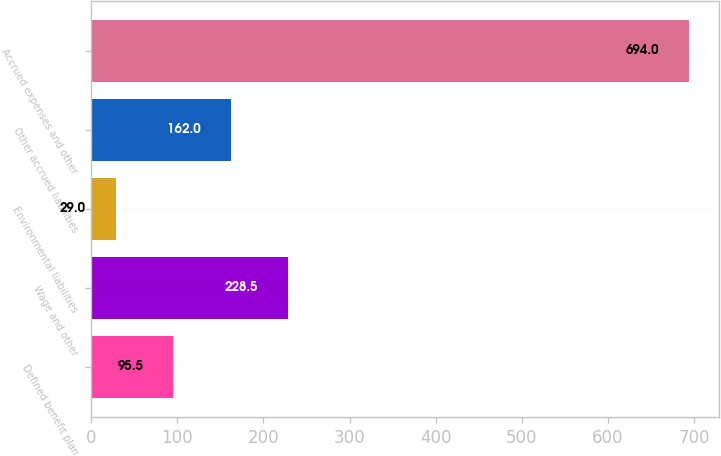Convert chart to OTSL. <chart><loc_0><loc_0><loc_500><loc_500><bar_chart><fcel>Defined benefit plan<fcel>Wage and other<fcel>Environmental liabilities<fcel>Other accrued liabilities<fcel>Accrued expenses and other<nl><fcel>95.5<fcel>228.5<fcel>29<fcel>162<fcel>694<nl></chart> 